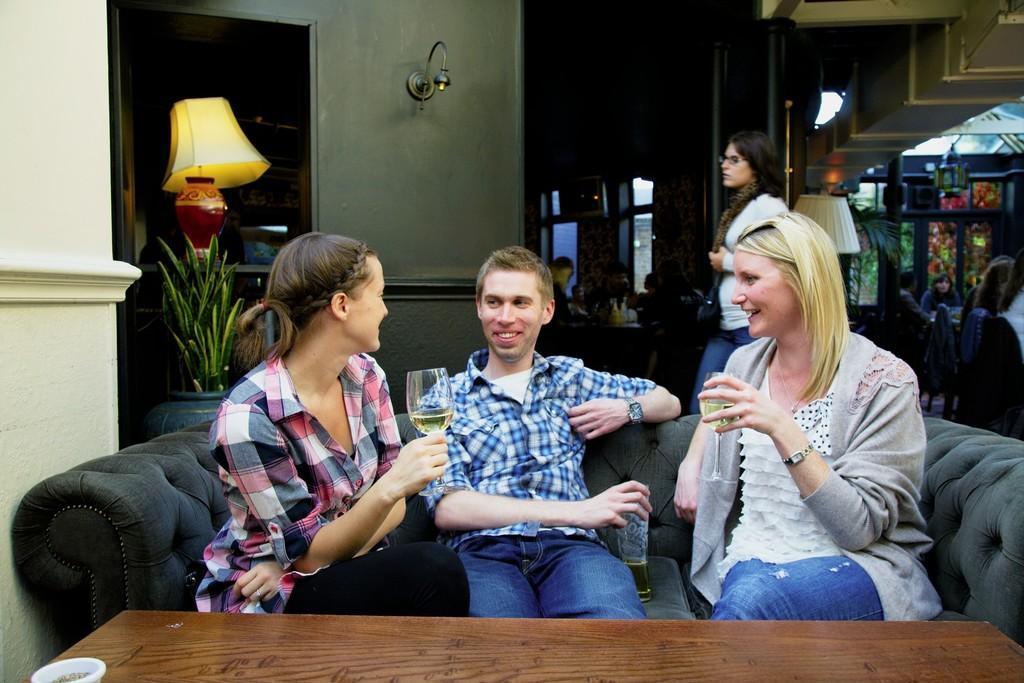How would you summarize this image in a sentence or two? This picture describes about group of people, in the middle of the given image a man and a woman is seated on the sofa, and they are holding glasses in their hand, in the background we can see couple of plants and a light. 